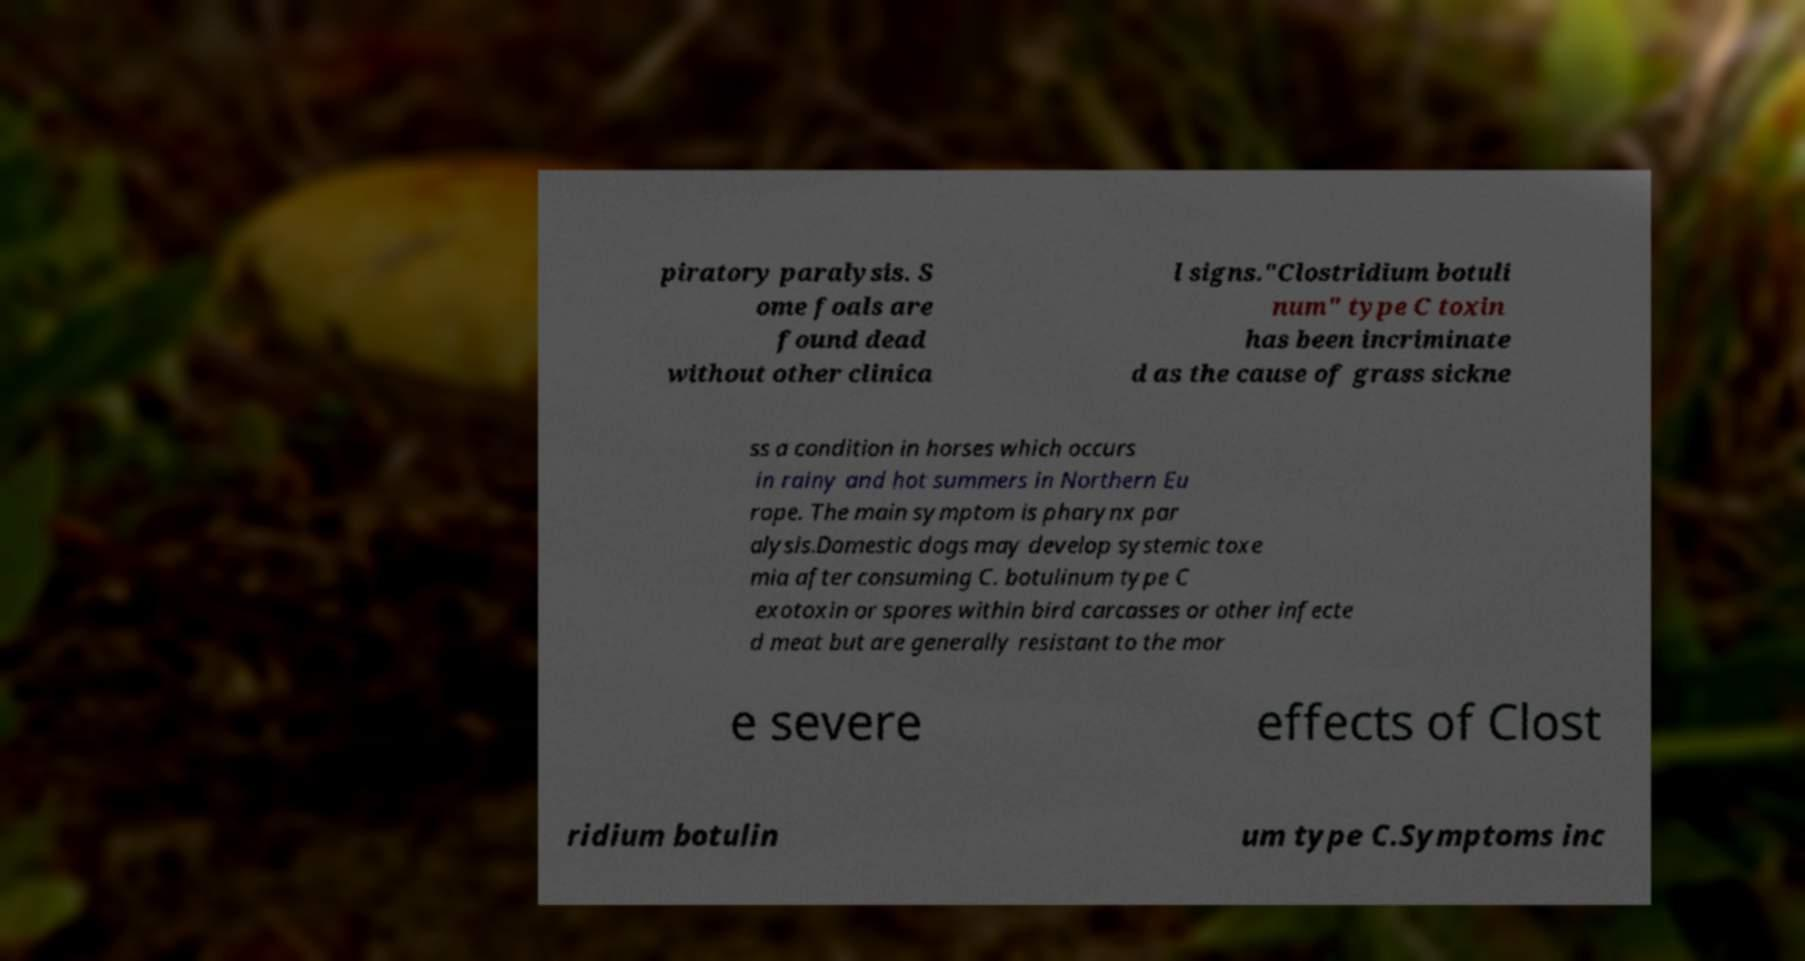Could you extract and type out the text from this image? piratory paralysis. S ome foals are found dead without other clinica l signs."Clostridium botuli num" type C toxin has been incriminate d as the cause of grass sickne ss a condition in horses which occurs in rainy and hot summers in Northern Eu rope. The main symptom is pharynx par alysis.Domestic dogs may develop systemic toxe mia after consuming C. botulinum type C exotoxin or spores within bird carcasses or other infecte d meat but are generally resistant to the mor e severe effects of Clost ridium botulin um type C.Symptoms inc 